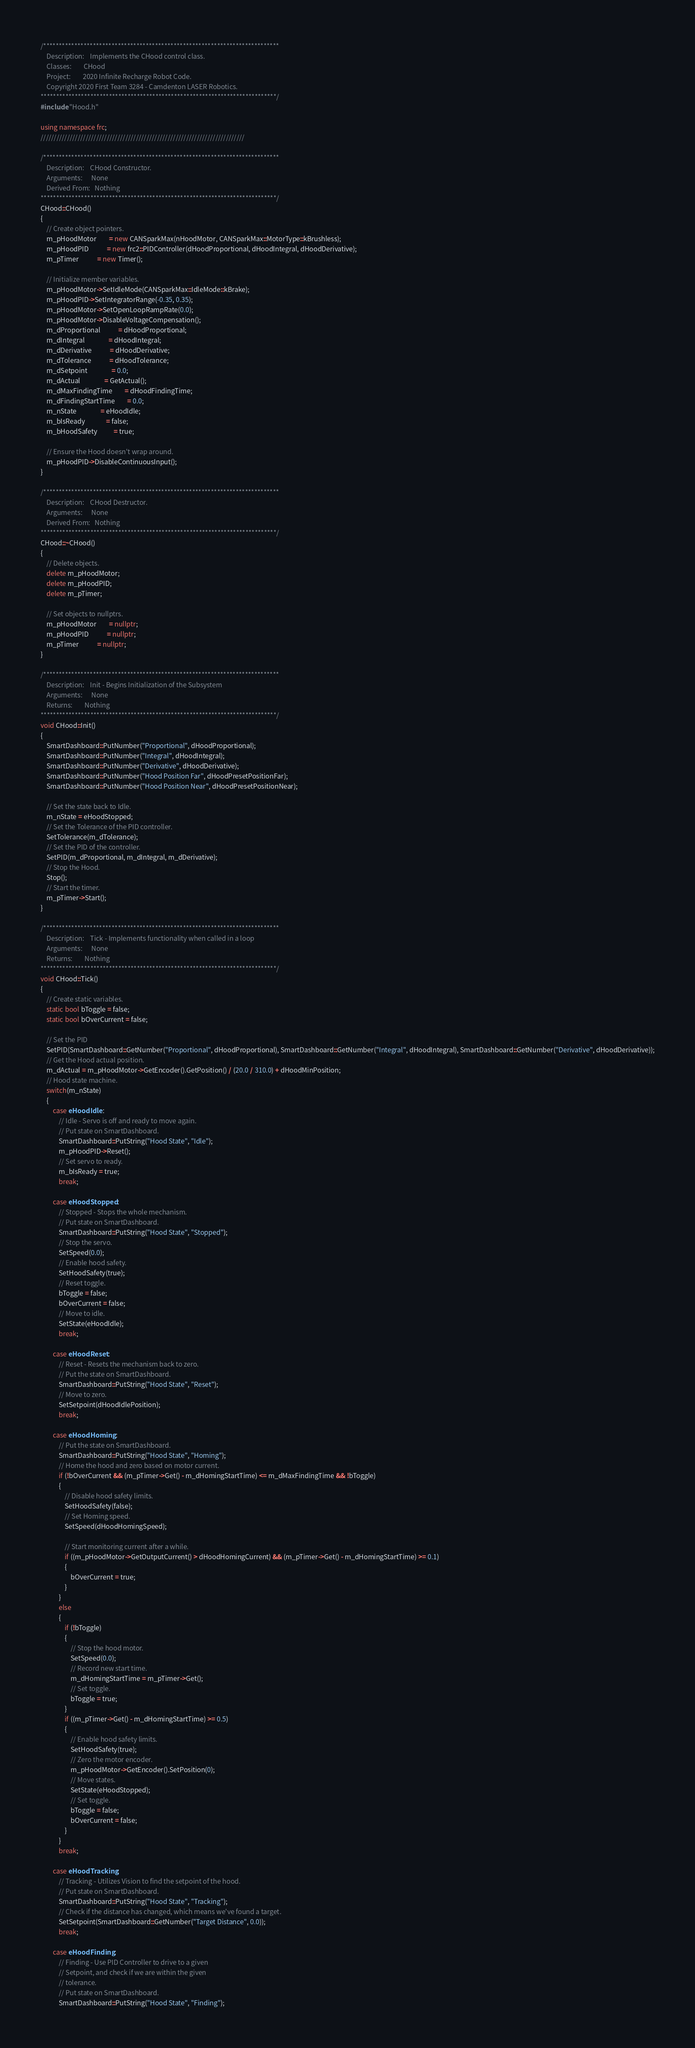<code> <loc_0><loc_0><loc_500><loc_500><_C++_>/****************************************************************************
    Description:	Implements the CHood control class.
    Classes:		CHood
    Project:		2020 Infinite Recharge Robot Code.
    Copyright 2020 First Team 3284 - Camdenton LASER Robotics.
****************************************************************************/
#include "Hood.h"

using namespace frc;
/////////////////////////////////////////////////////////////////////////////

/****************************************************************************
    Description:	CHood Constructor.
    Arguments:		None
    Derived From:	Nothing
****************************************************************************/
CHood::CHood()
{
    // Create object pointers.
    m_pHoodMotor        = new CANSparkMax(nHoodMotor, CANSparkMax::MotorType::kBrushless);
    m_pHoodPID			= new frc2::PIDController(dHoodProportional, dHoodIntegral, dHoodDerivative);
    m_pTimer            = new Timer();

    // Initialize member variables.
    m_pHoodMotor->SetIdleMode(CANSparkMax::IdleMode::kBrake);
    m_pHoodPID->SetIntegratorRange(-0.35, 0.35);
    m_pHoodMotor->SetOpenLoopRampRate(0.0);
    m_pHoodMotor->DisableVoltageCompensation();
    m_dProportional			= dHoodProportional;
    m_dIntegral				= dHoodIntegral;
    m_dDerivative			= dHoodDerivative;
    m_dTolerance			= dHoodTolerance;
    m_dSetpoint				= 0.0;
    m_dActual				= GetActual();
    m_dMaxFindingTime		= dHoodFindingTime;
    m_dFindingStartTime		= 0.0;
    m_nState				= eHoodIdle;
    m_bIsReady              = false;
    m_bHoodSafety           = true;

    // Ensure the Hood doesn't wrap around.
    m_pHoodPID->DisableContinuousInput();
}

/****************************************************************************
    Description:	CHood Destructor.
    Arguments:		None
    Derived From:	Nothing
****************************************************************************/
CHood::~CHood()
{
    // Delete objects.
    delete m_pHoodMotor;
    delete m_pHoodPID;
    delete m_pTimer;

    // Set objects to nullptrs.
    m_pHoodMotor		= nullptr;
    m_pHoodPID			= nullptr;
    m_pTimer            = nullptr;
}

/****************************************************************************
    Description:	Init - Begins Initialization of the Subsystem
    Arguments:		None
    Returns:		Nothing
****************************************************************************/
void CHood::Init()
{
    SmartDashboard::PutNumber("Proportional", dHoodProportional);
    SmartDashboard::PutNumber("Integral", dHoodIntegral);
    SmartDashboard::PutNumber("Derivative", dHoodDerivative);
    SmartDashboard::PutNumber("Hood Position Far", dHoodPresetPositionFar);
    SmartDashboard::PutNumber("Hood Position Near", dHoodPresetPositionNear);

    // Set the state back to Idle.
    m_nState = eHoodStopped;
    // Set the Tolerance of the PID controller.
    SetTolerance(m_dTolerance);
    // Set the PID of the controller.
    SetPID(m_dProportional, m_dIntegral, m_dDerivative);
    // Stop the Hood.
    Stop();
    // Start the timer.
    m_pTimer->Start();
}

/****************************************************************************
    Description:	Tick - Implements functionality when called in a loop
    Arguments:		None
    Returns:		Nothing
****************************************************************************/
void CHood::Tick()
{
    // Create static variables.
    static bool bToggle = false;
    static bool bOverCurrent = false;

    // Set the PID
    SetPID(SmartDashboard::GetNumber("Proportional", dHoodProportional), SmartDashboard::GetNumber("Integral", dHoodIntegral), SmartDashboard::GetNumber("Derivative", dHoodDerivative));
    // Get the Hood actual position.
    m_dActual = m_pHoodMotor->GetEncoder().GetPosition() / (20.0 / 310.0) + dHoodMinPosition;
    // Hood state machine.
    switch(m_nState)
    {
        case eHoodIdle :
            // Idle - Servo is off and ready to move again.
            // Put state on SmartDashboard.
            SmartDashboard::PutString("Hood State", "Idle");
            m_pHoodPID->Reset();
            // Set servo to ready.
            m_bIsReady = true;
            break;

        case eHoodStopped :
            // Stopped - Stops the whole mechanism.
            // Put state on SmartDashboard.
            SmartDashboard::PutString("Hood State", "Stopped");
            // Stop the servo.
            SetSpeed(0.0);
            // Enable hood safety.
            SetHoodSafety(true);
            // Reset toggle.
            bToggle = false;
            bOverCurrent = false;
            // Move to idle.
            SetState(eHoodIdle);
            break;

        case eHoodReset :
            // Reset - Resets the mechanism back to zero.
            // Put the state on SmartDashboard.
            SmartDashboard::PutString("Hood State", "Reset");
            // Move to zero.
            SetSetpoint(dHoodIdlePosition);
            break;

        case eHoodHoming :
            // Put the state on SmartDashboard.
            SmartDashboard::PutString("Hood State", "Homing");
            // Home the hood and zero based on motor current.
            if (!bOverCurrent && (m_pTimer->Get() - m_dHomingStartTime) <= m_dMaxFindingTime && !bToggle)
            {
                // Disable hood safety limits.
                SetHoodSafety(false);
                // Set Homing speed.
                SetSpeed(dHoodHomingSpeed);

                // Start monitoring current after a while.
                if ((m_pHoodMotor->GetOutputCurrent() > dHoodHomingCurrent) && (m_pTimer->Get() - m_dHomingStartTime) >= 0.1)
                {
                    bOverCurrent = true;
                }
            }
            else
            {
                if (!bToggle)
                {
                    // Stop the hood motor.
                    SetSpeed(0.0);
                    // Record new start time.
                    m_dHomingStartTime = m_pTimer->Get();
                    // Set toggle.
                    bToggle = true;
                }
                if ((m_pTimer->Get() - m_dHomingStartTime) >= 0.5)
                {
                    // Enable hood safety limits.
                    SetHoodSafety(true);
                    // Zero the motor encoder.
                    m_pHoodMotor->GetEncoder().SetPosition(0);
                    // Move states.
                    SetState(eHoodStopped);
                    // Set toggle.
                    bToggle = false;
                    bOverCurrent = false;
                }
            }
            break;
            
        case eHoodTracking :
            // Tracking - Utilizes Vision to find the setpoint of the hood.
            // Put state on SmartDashboard.
            SmartDashboard::PutString("Hood State", "Tracking");
            // Check if the distance has changed, which means we've found a target.
            SetSetpoint(SmartDashboard::GetNumber("Target Distance", 0.0));
            break;

        case eHoodFinding :
            // Finding - Use PID Controller to drive to a given
            // Setpoint, and check if we are within the given
            // tolerance.
            // Put state on SmartDashboard.
            SmartDashboard::PutString("Hood State", "Finding");</code> 